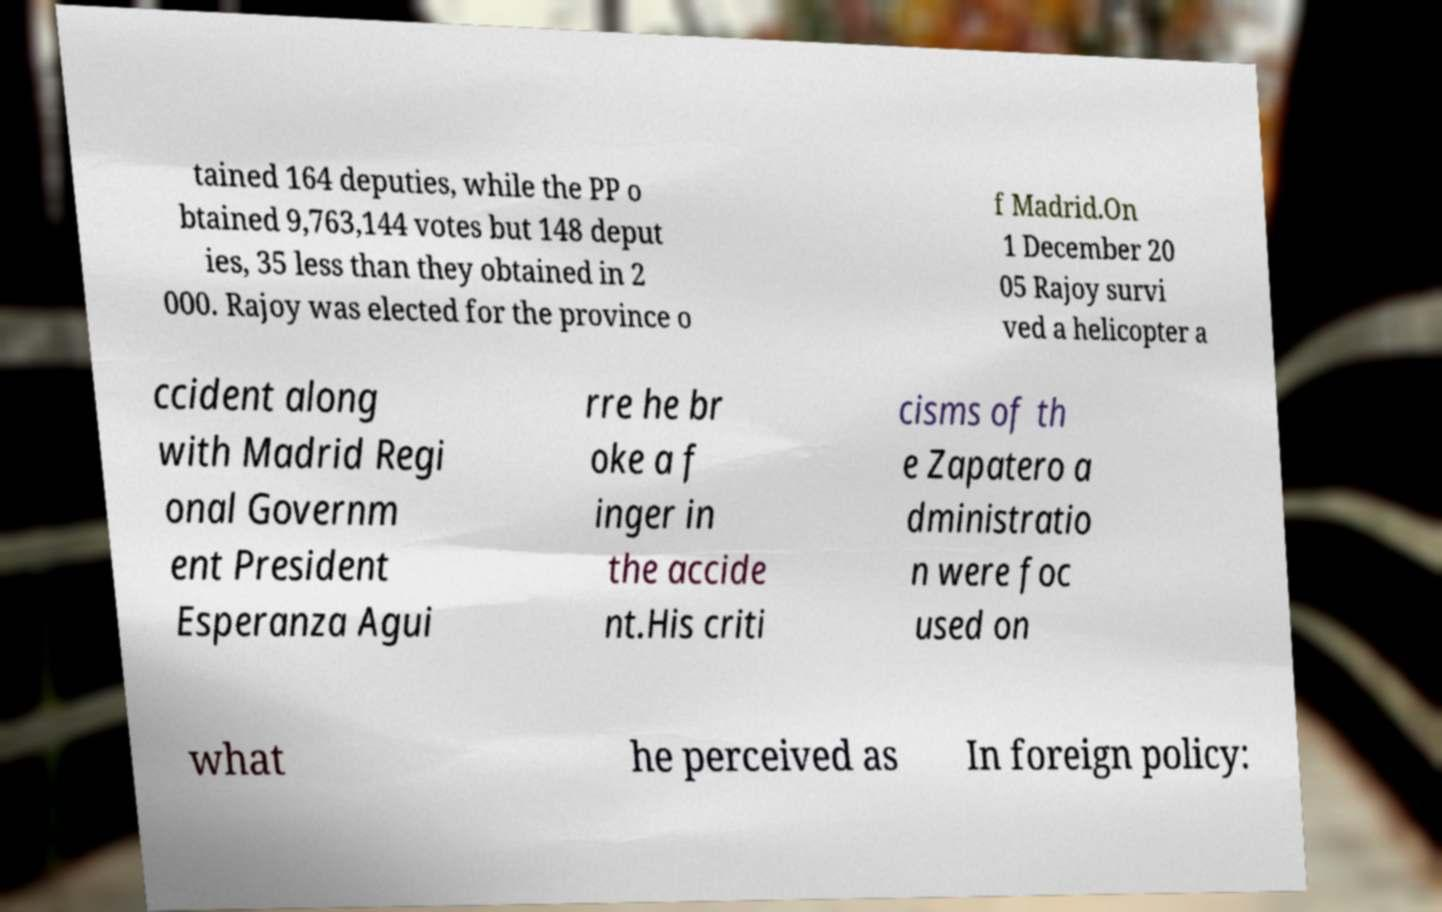I need the written content from this picture converted into text. Can you do that? tained 164 deputies, while the PP o btained 9,763,144 votes but 148 deput ies, 35 less than they obtained in 2 000. Rajoy was elected for the province o f Madrid.On 1 December 20 05 Rajoy survi ved a helicopter a ccident along with Madrid Regi onal Governm ent President Esperanza Agui rre he br oke a f inger in the accide nt.His criti cisms of th e Zapatero a dministratio n were foc used on what he perceived as In foreign policy: 